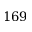<formula> <loc_0><loc_0><loc_500><loc_500>1 6 9</formula> 